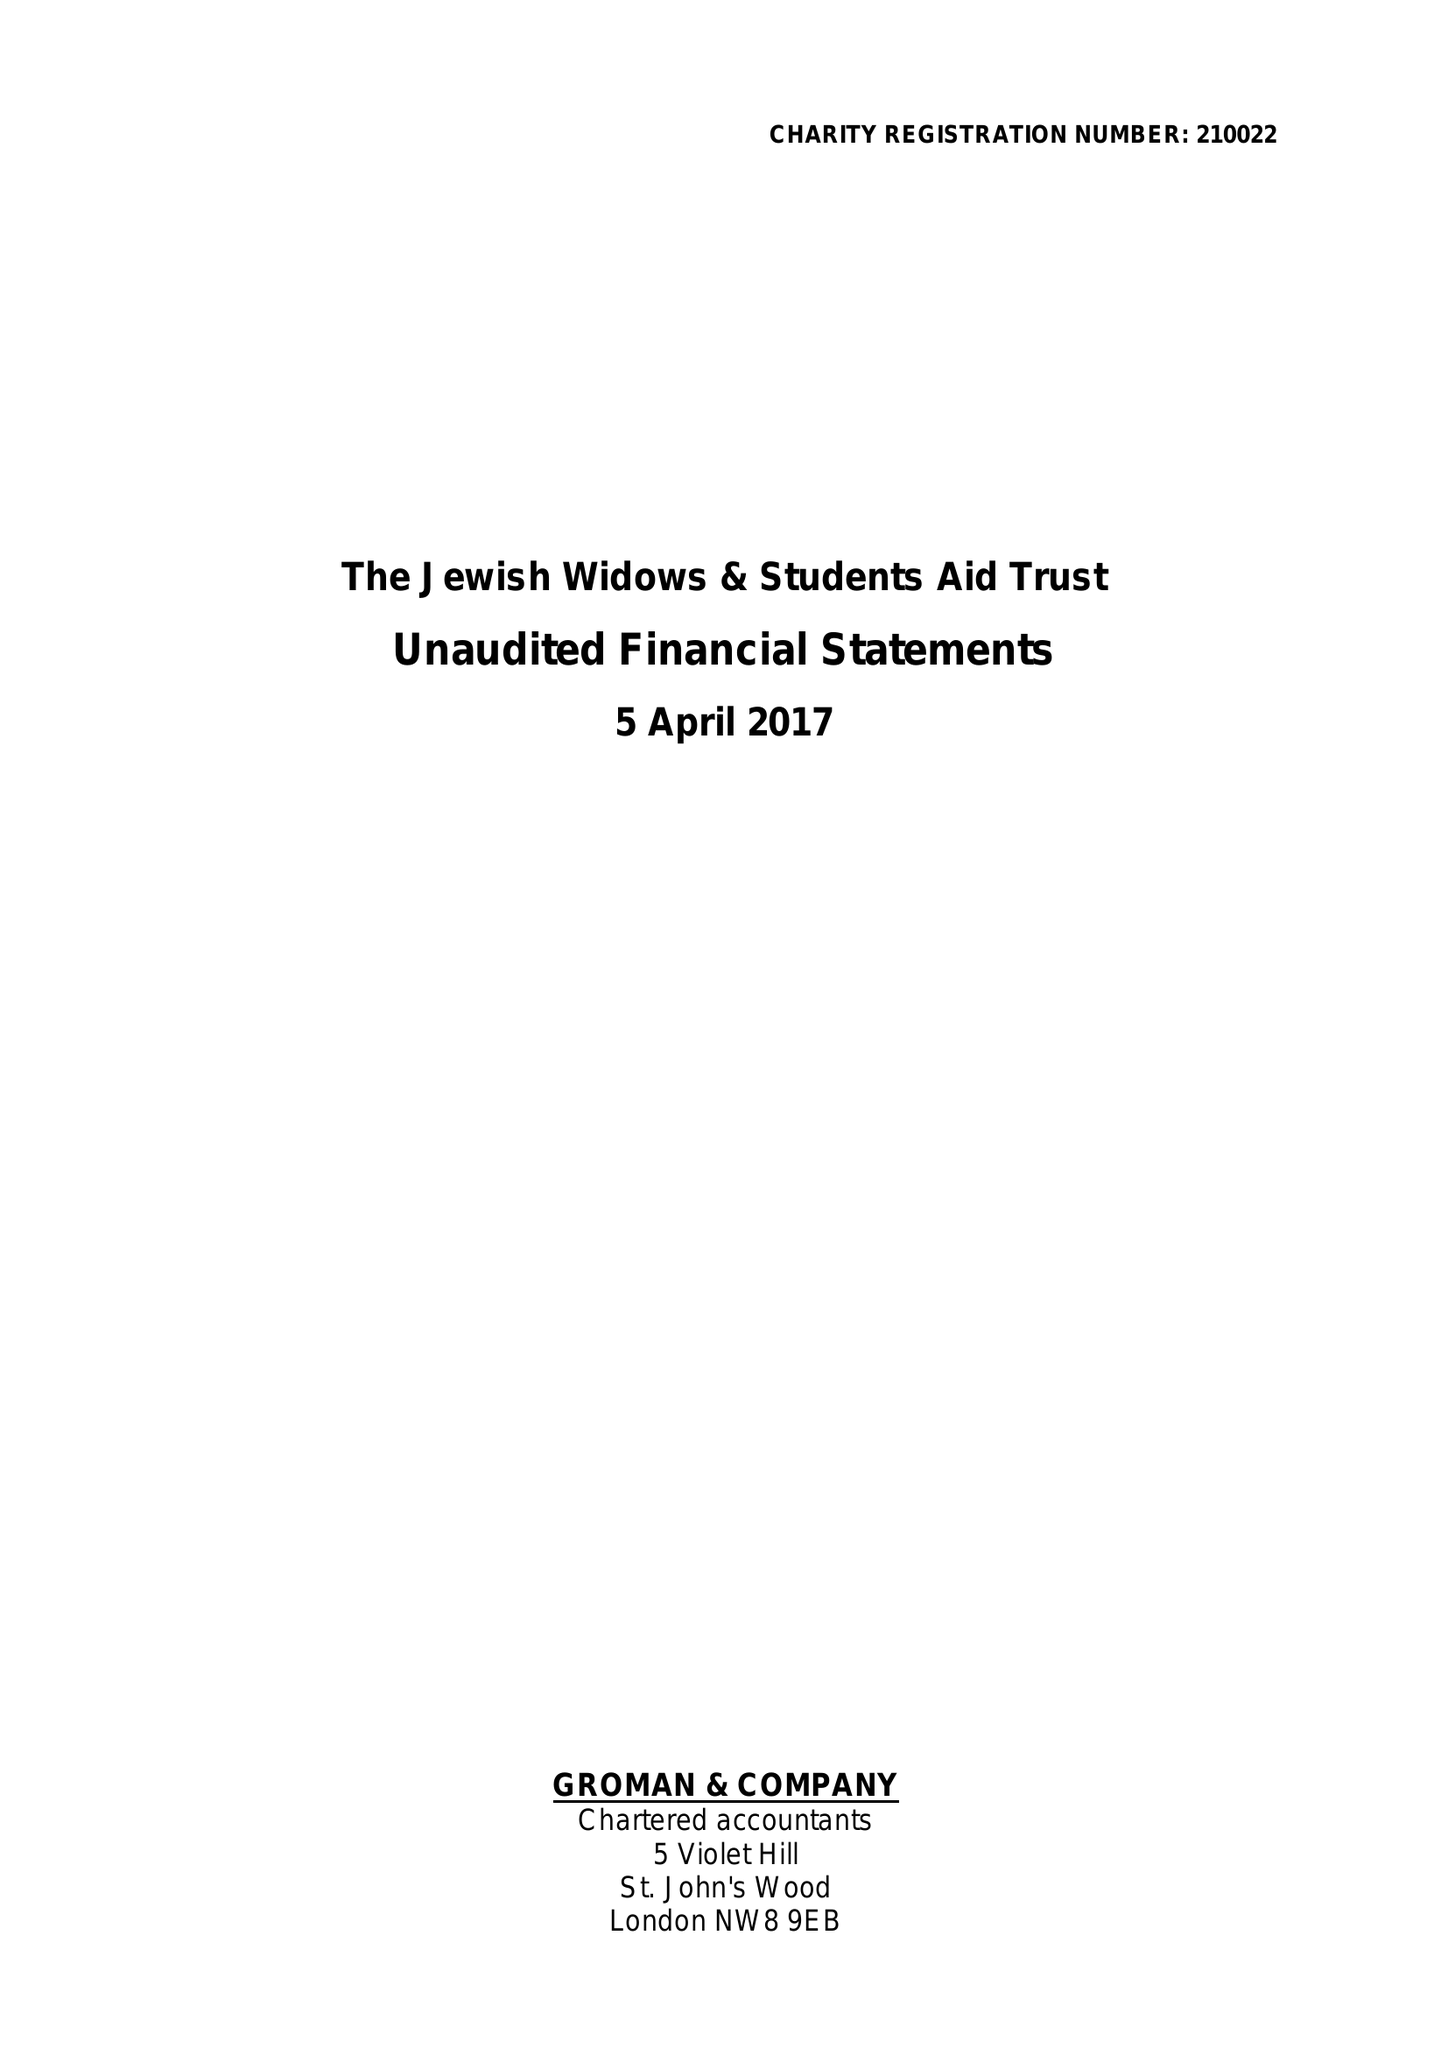What is the value for the spending_annually_in_british_pounds?
Answer the question using a single word or phrase. 59533.00 